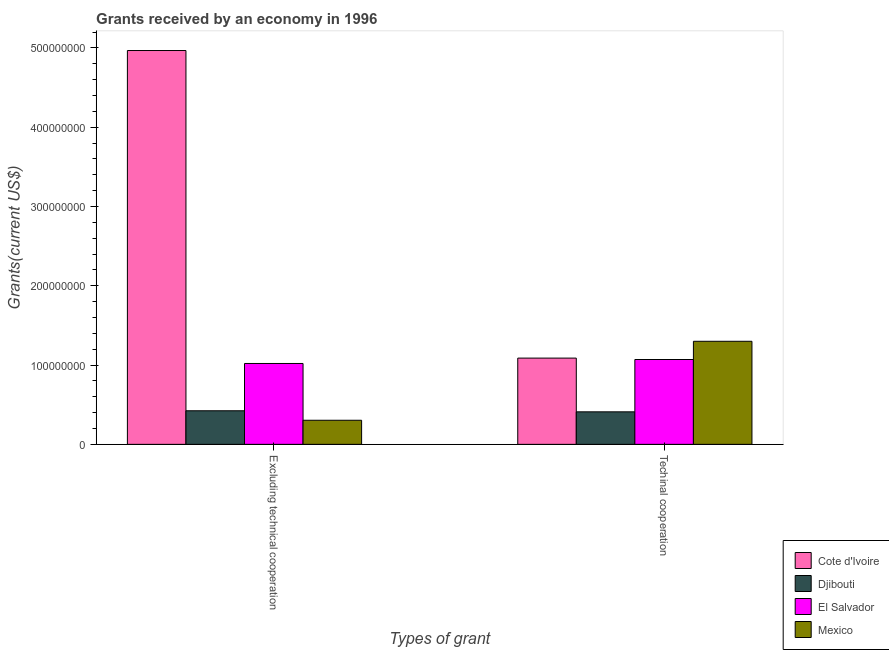Are the number of bars per tick equal to the number of legend labels?
Your answer should be compact. Yes. Are the number of bars on each tick of the X-axis equal?
Offer a terse response. Yes. What is the label of the 2nd group of bars from the left?
Your response must be concise. Techinal cooperation. What is the amount of grants received(excluding technical cooperation) in Djibouti?
Your answer should be compact. 4.24e+07. Across all countries, what is the maximum amount of grants received(including technical cooperation)?
Provide a succinct answer. 1.30e+08. Across all countries, what is the minimum amount of grants received(excluding technical cooperation)?
Your answer should be compact. 3.04e+07. In which country was the amount of grants received(excluding technical cooperation) maximum?
Offer a terse response. Cote d'Ivoire. In which country was the amount of grants received(including technical cooperation) minimum?
Offer a terse response. Djibouti. What is the total amount of grants received(including technical cooperation) in the graph?
Offer a terse response. 3.87e+08. What is the difference between the amount of grants received(including technical cooperation) in Cote d'Ivoire and that in Djibouti?
Give a very brief answer. 6.78e+07. What is the difference between the amount of grants received(excluding technical cooperation) in Mexico and the amount of grants received(including technical cooperation) in Cote d'Ivoire?
Your response must be concise. -7.84e+07. What is the average amount of grants received(excluding technical cooperation) per country?
Ensure brevity in your answer.  1.68e+08. What is the difference between the amount of grants received(excluding technical cooperation) and amount of grants received(including technical cooperation) in Cote d'Ivoire?
Give a very brief answer. 3.88e+08. What is the ratio of the amount of grants received(excluding technical cooperation) in Djibouti to that in Cote d'Ivoire?
Ensure brevity in your answer.  0.09. What does the 3rd bar from the right in Techinal cooperation represents?
Provide a succinct answer. Djibouti. Are all the bars in the graph horizontal?
Offer a terse response. No. Are the values on the major ticks of Y-axis written in scientific E-notation?
Make the answer very short. No. Does the graph contain grids?
Your response must be concise. No. How many legend labels are there?
Make the answer very short. 4. How are the legend labels stacked?
Make the answer very short. Vertical. What is the title of the graph?
Offer a very short reply. Grants received by an economy in 1996. Does "Macedonia" appear as one of the legend labels in the graph?
Offer a very short reply. No. What is the label or title of the X-axis?
Your answer should be very brief. Types of grant. What is the label or title of the Y-axis?
Your answer should be compact. Grants(current US$). What is the Grants(current US$) in Cote d'Ivoire in Excluding technical cooperation?
Your answer should be compact. 4.97e+08. What is the Grants(current US$) in Djibouti in Excluding technical cooperation?
Keep it short and to the point. 4.24e+07. What is the Grants(current US$) of El Salvador in Excluding technical cooperation?
Offer a terse response. 1.02e+08. What is the Grants(current US$) of Mexico in Excluding technical cooperation?
Keep it short and to the point. 3.04e+07. What is the Grants(current US$) of Cote d'Ivoire in Techinal cooperation?
Make the answer very short. 1.09e+08. What is the Grants(current US$) in Djibouti in Techinal cooperation?
Ensure brevity in your answer.  4.10e+07. What is the Grants(current US$) of El Salvador in Techinal cooperation?
Offer a terse response. 1.07e+08. What is the Grants(current US$) of Mexico in Techinal cooperation?
Provide a succinct answer. 1.30e+08. Across all Types of grant, what is the maximum Grants(current US$) of Cote d'Ivoire?
Offer a very short reply. 4.97e+08. Across all Types of grant, what is the maximum Grants(current US$) in Djibouti?
Give a very brief answer. 4.24e+07. Across all Types of grant, what is the maximum Grants(current US$) of El Salvador?
Give a very brief answer. 1.07e+08. Across all Types of grant, what is the maximum Grants(current US$) in Mexico?
Your answer should be compact. 1.30e+08. Across all Types of grant, what is the minimum Grants(current US$) of Cote d'Ivoire?
Make the answer very short. 1.09e+08. Across all Types of grant, what is the minimum Grants(current US$) of Djibouti?
Offer a very short reply. 4.10e+07. Across all Types of grant, what is the minimum Grants(current US$) in El Salvador?
Offer a very short reply. 1.02e+08. Across all Types of grant, what is the minimum Grants(current US$) in Mexico?
Your answer should be compact. 3.04e+07. What is the total Grants(current US$) of Cote d'Ivoire in the graph?
Ensure brevity in your answer.  6.06e+08. What is the total Grants(current US$) of Djibouti in the graph?
Make the answer very short. 8.34e+07. What is the total Grants(current US$) of El Salvador in the graph?
Ensure brevity in your answer.  2.09e+08. What is the total Grants(current US$) in Mexico in the graph?
Keep it short and to the point. 1.60e+08. What is the difference between the Grants(current US$) in Cote d'Ivoire in Excluding technical cooperation and that in Techinal cooperation?
Keep it short and to the point. 3.88e+08. What is the difference between the Grants(current US$) in Djibouti in Excluding technical cooperation and that in Techinal cooperation?
Your answer should be compact. 1.34e+06. What is the difference between the Grants(current US$) of El Salvador in Excluding technical cooperation and that in Techinal cooperation?
Provide a short and direct response. -5.00e+06. What is the difference between the Grants(current US$) in Mexico in Excluding technical cooperation and that in Techinal cooperation?
Give a very brief answer. -9.96e+07. What is the difference between the Grants(current US$) in Cote d'Ivoire in Excluding technical cooperation and the Grants(current US$) in Djibouti in Techinal cooperation?
Make the answer very short. 4.56e+08. What is the difference between the Grants(current US$) of Cote d'Ivoire in Excluding technical cooperation and the Grants(current US$) of El Salvador in Techinal cooperation?
Your response must be concise. 3.90e+08. What is the difference between the Grants(current US$) of Cote d'Ivoire in Excluding technical cooperation and the Grants(current US$) of Mexico in Techinal cooperation?
Your answer should be compact. 3.67e+08. What is the difference between the Grants(current US$) of Djibouti in Excluding technical cooperation and the Grants(current US$) of El Salvador in Techinal cooperation?
Your response must be concise. -6.46e+07. What is the difference between the Grants(current US$) of Djibouti in Excluding technical cooperation and the Grants(current US$) of Mexico in Techinal cooperation?
Provide a short and direct response. -8.76e+07. What is the difference between the Grants(current US$) of El Salvador in Excluding technical cooperation and the Grants(current US$) of Mexico in Techinal cooperation?
Give a very brief answer. -2.80e+07. What is the average Grants(current US$) in Cote d'Ivoire per Types of grant?
Your response must be concise. 3.03e+08. What is the average Grants(current US$) in Djibouti per Types of grant?
Keep it short and to the point. 4.17e+07. What is the average Grants(current US$) in El Salvador per Types of grant?
Give a very brief answer. 1.05e+08. What is the average Grants(current US$) in Mexico per Types of grant?
Provide a succinct answer. 8.02e+07. What is the difference between the Grants(current US$) in Cote d'Ivoire and Grants(current US$) in Djibouti in Excluding technical cooperation?
Give a very brief answer. 4.54e+08. What is the difference between the Grants(current US$) in Cote d'Ivoire and Grants(current US$) in El Salvador in Excluding technical cooperation?
Your answer should be very brief. 3.95e+08. What is the difference between the Grants(current US$) of Cote d'Ivoire and Grants(current US$) of Mexico in Excluding technical cooperation?
Offer a terse response. 4.66e+08. What is the difference between the Grants(current US$) of Djibouti and Grants(current US$) of El Salvador in Excluding technical cooperation?
Your answer should be compact. -5.96e+07. What is the difference between the Grants(current US$) in Djibouti and Grants(current US$) in Mexico in Excluding technical cooperation?
Your response must be concise. 1.20e+07. What is the difference between the Grants(current US$) in El Salvador and Grants(current US$) in Mexico in Excluding technical cooperation?
Provide a short and direct response. 7.16e+07. What is the difference between the Grants(current US$) in Cote d'Ivoire and Grants(current US$) in Djibouti in Techinal cooperation?
Provide a succinct answer. 6.78e+07. What is the difference between the Grants(current US$) in Cote d'Ivoire and Grants(current US$) in El Salvador in Techinal cooperation?
Your response must be concise. 1.78e+06. What is the difference between the Grants(current US$) of Cote d'Ivoire and Grants(current US$) of Mexico in Techinal cooperation?
Ensure brevity in your answer.  -2.12e+07. What is the difference between the Grants(current US$) of Djibouti and Grants(current US$) of El Salvador in Techinal cooperation?
Provide a succinct answer. -6.60e+07. What is the difference between the Grants(current US$) of Djibouti and Grants(current US$) of Mexico in Techinal cooperation?
Your response must be concise. -8.90e+07. What is the difference between the Grants(current US$) of El Salvador and Grants(current US$) of Mexico in Techinal cooperation?
Give a very brief answer. -2.30e+07. What is the ratio of the Grants(current US$) in Cote d'Ivoire in Excluding technical cooperation to that in Techinal cooperation?
Make the answer very short. 4.57. What is the ratio of the Grants(current US$) of Djibouti in Excluding technical cooperation to that in Techinal cooperation?
Ensure brevity in your answer.  1.03. What is the ratio of the Grants(current US$) of El Salvador in Excluding technical cooperation to that in Techinal cooperation?
Keep it short and to the point. 0.95. What is the ratio of the Grants(current US$) of Mexico in Excluding technical cooperation to that in Techinal cooperation?
Provide a short and direct response. 0.23. What is the difference between the highest and the second highest Grants(current US$) of Cote d'Ivoire?
Make the answer very short. 3.88e+08. What is the difference between the highest and the second highest Grants(current US$) of Djibouti?
Give a very brief answer. 1.34e+06. What is the difference between the highest and the second highest Grants(current US$) of Mexico?
Offer a very short reply. 9.96e+07. What is the difference between the highest and the lowest Grants(current US$) in Cote d'Ivoire?
Ensure brevity in your answer.  3.88e+08. What is the difference between the highest and the lowest Grants(current US$) of Djibouti?
Make the answer very short. 1.34e+06. What is the difference between the highest and the lowest Grants(current US$) in El Salvador?
Ensure brevity in your answer.  5.00e+06. What is the difference between the highest and the lowest Grants(current US$) of Mexico?
Make the answer very short. 9.96e+07. 